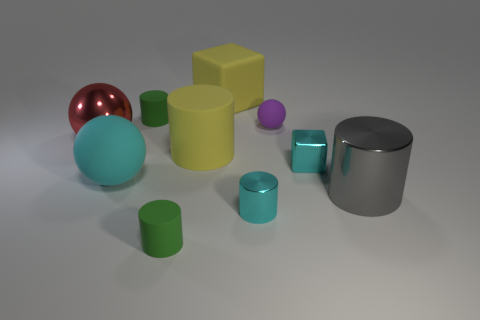Subtract all tiny metal cylinders. How many cylinders are left? 4 Subtract all gray cylinders. How many cylinders are left? 4 Subtract all red cylinders. Subtract all purple balls. How many cylinders are left? 5 Subtract all cubes. How many objects are left? 8 Add 5 small cyan cylinders. How many small cyan cylinders exist? 6 Subtract 1 cyan spheres. How many objects are left? 9 Subtract all gray metallic cylinders. Subtract all tiny yellow blocks. How many objects are left? 9 Add 5 tiny cyan cylinders. How many tiny cyan cylinders are left? 6 